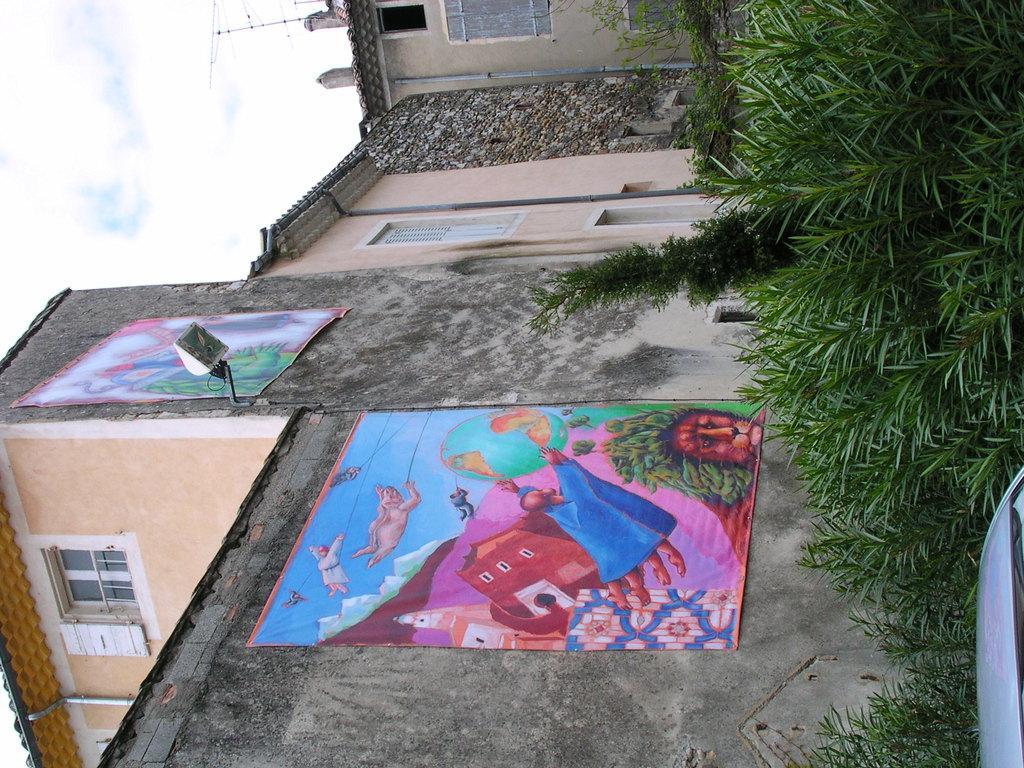In one or two sentences, can you explain what this image depicts? In this image there is a vehicle, grass, plants, buildings, light, banners on the building, antenna, sky. 